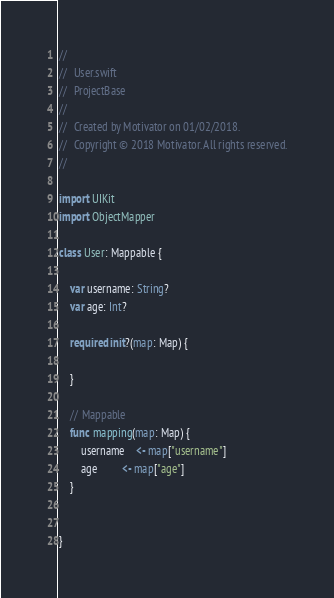<code> <loc_0><loc_0><loc_500><loc_500><_Swift_>//
//  User.swift
//  ProjectBase
//
//  Created by Motivator on 01/02/2018.
//  Copyright © 2018 Motivator. All rights reserved.
//

import UIKit
import ObjectMapper

class User: Mappable {
    
    var username: String?
    var age: Int?
    
    required init?(map: Map) {
        
    }
    
    // Mappable
    func mapping(map: Map) {
        username    <- map["username"]
        age         <- map["age"]
    }
    

}
</code> 